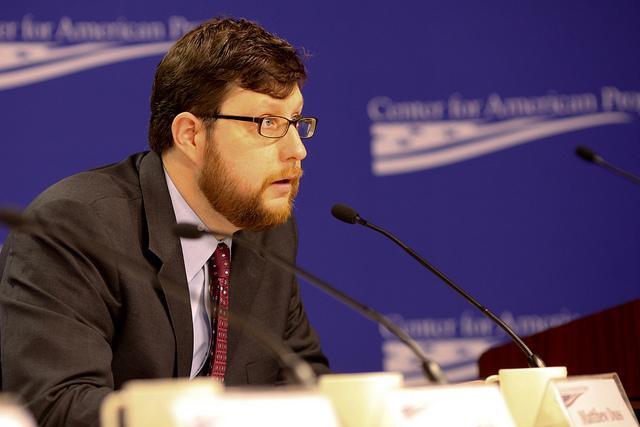How many cups are visible?
Give a very brief answer. 3. 